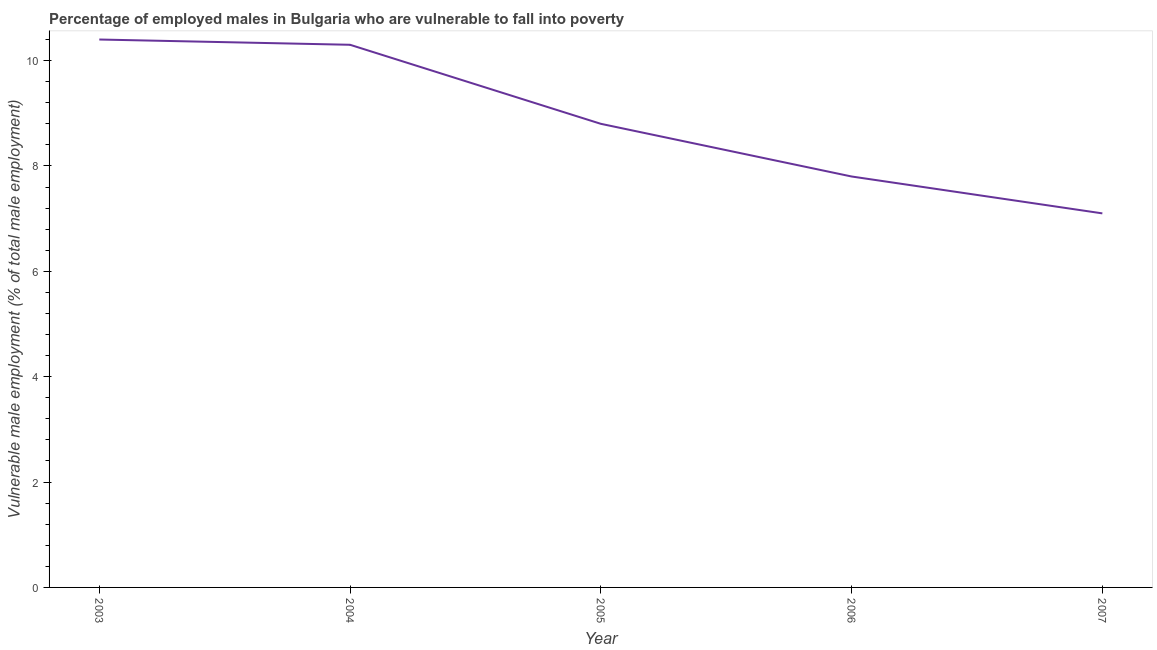What is the percentage of employed males who are vulnerable to fall into poverty in 2004?
Offer a very short reply. 10.3. Across all years, what is the maximum percentage of employed males who are vulnerable to fall into poverty?
Your answer should be compact. 10.4. Across all years, what is the minimum percentage of employed males who are vulnerable to fall into poverty?
Keep it short and to the point. 7.1. In which year was the percentage of employed males who are vulnerable to fall into poverty maximum?
Your answer should be compact. 2003. What is the sum of the percentage of employed males who are vulnerable to fall into poverty?
Offer a terse response. 44.4. What is the difference between the percentage of employed males who are vulnerable to fall into poverty in 2005 and 2006?
Your response must be concise. 1. What is the average percentage of employed males who are vulnerable to fall into poverty per year?
Your answer should be very brief. 8.88. What is the median percentage of employed males who are vulnerable to fall into poverty?
Offer a terse response. 8.8. In how many years, is the percentage of employed males who are vulnerable to fall into poverty greater than 1.6 %?
Offer a terse response. 5. What is the ratio of the percentage of employed males who are vulnerable to fall into poverty in 2004 to that in 2007?
Offer a terse response. 1.45. Is the percentage of employed males who are vulnerable to fall into poverty in 2006 less than that in 2007?
Offer a very short reply. No. Is the difference between the percentage of employed males who are vulnerable to fall into poverty in 2003 and 2006 greater than the difference between any two years?
Ensure brevity in your answer.  No. What is the difference between the highest and the second highest percentage of employed males who are vulnerable to fall into poverty?
Your response must be concise. 0.1. What is the difference between the highest and the lowest percentage of employed males who are vulnerable to fall into poverty?
Offer a very short reply. 3.3. In how many years, is the percentage of employed males who are vulnerable to fall into poverty greater than the average percentage of employed males who are vulnerable to fall into poverty taken over all years?
Provide a short and direct response. 2. How many lines are there?
Give a very brief answer. 1. What is the difference between two consecutive major ticks on the Y-axis?
Provide a succinct answer. 2. Are the values on the major ticks of Y-axis written in scientific E-notation?
Your response must be concise. No. Does the graph contain grids?
Provide a short and direct response. No. What is the title of the graph?
Offer a very short reply. Percentage of employed males in Bulgaria who are vulnerable to fall into poverty. What is the label or title of the Y-axis?
Provide a short and direct response. Vulnerable male employment (% of total male employment). What is the Vulnerable male employment (% of total male employment) in 2003?
Your answer should be compact. 10.4. What is the Vulnerable male employment (% of total male employment) in 2004?
Offer a very short reply. 10.3. What is the Vulnerable male employment (% of total male employment) in 2005?
Give a very brief answer. 8.8. What is the Vulnerable male employment (% of total male employment) of 2006?
Make the answer very short. 7.8. What is the Vulnerable male employment (% of total male employment) of 2007?
Offer a very short reply. 7.1. What is the difference between the Vulnerable male employment (% of total male employment) in 2003 and 2004?
Keep it short and to the point. 0.1. What is the difference between the Vulnerable male employment (% of total male employment) in 2003 and 2007?
Offer a terse response. 3.3. What is the difference between the Vulnerable male employment (% of total male employment) in 2004 and 2007?
Your response must be concise. 3.2. What is the difference between the Vulnerable male employment (% of total male employment) in 2005 and 2006?
Keep it short and to the point. 1. What is the difference between the Vulnerable male employment (% of total male employment) in 2005 and 2007?
Ensure brevity in your answer.  1.7. What is the difference between the Vulnerable male employment (% of total male employment) in 2006 and 2007?
Offer a terse response. 0.7. What is the ratio of the Vulnerable male employment (% of total male employment) in 2003 to that in 2004?
Give a very brief answer. 1.01. What is the ratio of the Vulnerable male employment (% of total male employment) in 2003 to that in 2005?
Keep it short and to the point. 1.18. What is the ratio of the Vulnerable male employment (% of total male employment) in 2003 to that in 2006?
Make the answer very short. 1.33. What is the ratio of the Vulnerable male employment (% of total male employment) in 2003 to that in 2007?
Provide a succinct answer. 1.47. What is the ratio of the Vulnerable male employment (% of total male employment) in 2004 to that in 2005?
Give a very brief answer. 1.17. What is the ratio of the Vulnerable male employment (% of total male employment) in 2004 to that in 2006?
Provide a short and direct response. 1.32. What is the ratio of the Vulnerable male employment (% of total male employment) in 2004 to that in 2007?
Provide a succinct answer. 1.45. What is the ratio of the Vulnerable male employment (% of total male employment) in 2005 to that in 2006?
Make the answer very short. 1.13. What is the ratio of the Vulnerable male employment (% of total male employment) in 2005 to that in 2007?
Give a very brief answer. 1.24. What is the ratio of the Vulnerable male employment (% of total male employment) in 2006 to that in 2007?
Make the answer very short. 1.1. 